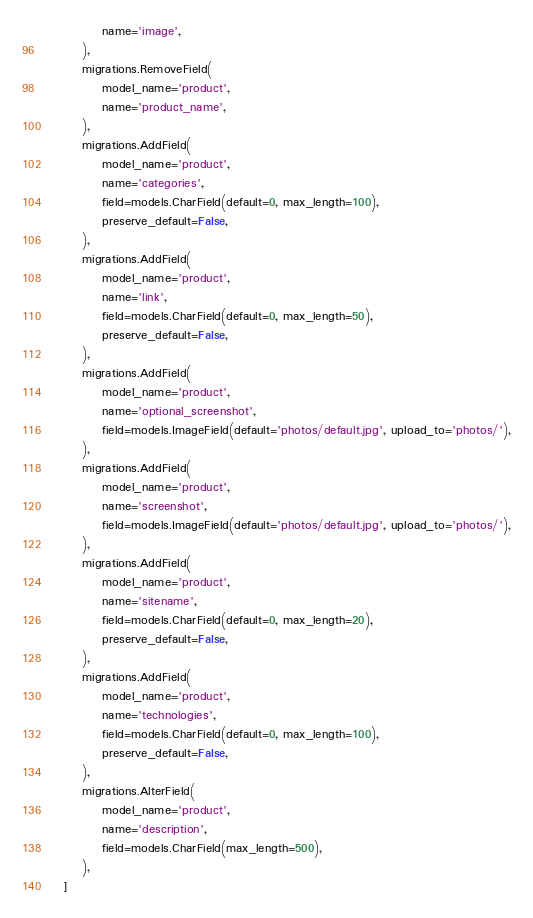Convert code to text. <code><loc_0><loc_0><loc_500><loc_500><_Python_>            name='image',
        ),
        migrations.RemoveField(
            model_name='product',
            name='product_name',
        ),
        migrations.AddField(
            model_name='product',
            name='categories',
            field=models.CharField(default=0, max_length=100),
            preserve_default=False,
        ),
        migrations.AddField(
            model_name='product',
            name='link',
            field=models.CharField(default=0, max_length=50),
            preserve_default=False,
        ),
        migrations.AddField(
            model_name='product',
            name='optional_screenshot',
            field=models.ImageField(default='photos/default.jpg', upload_to='photos/'),
        ),
        migrations.AddField(
            model_name='product',
            name='screenshot',
            field=models.ImageField(default='photos/default.jpg', upload_to='photos/'),
        ),
        migrations.AddField(
            model_name='product',
            name='sitename',
            field=models.CharField(default=0, max_length=20),
            preserve_default=False,
        ),
        migrations.AddField(
            model_name='product',
            name='technologies',
            field=models.CharField(default=0, max_length=100),
            preserve_default=False,
        ),
        migrations.AlterField(
            model_name='product',
            name='description',
            field=models.CharField(max_length=500),
        ),
    ]
</code> 